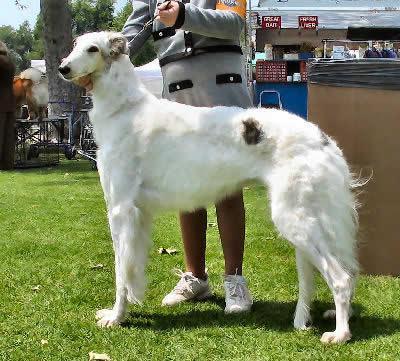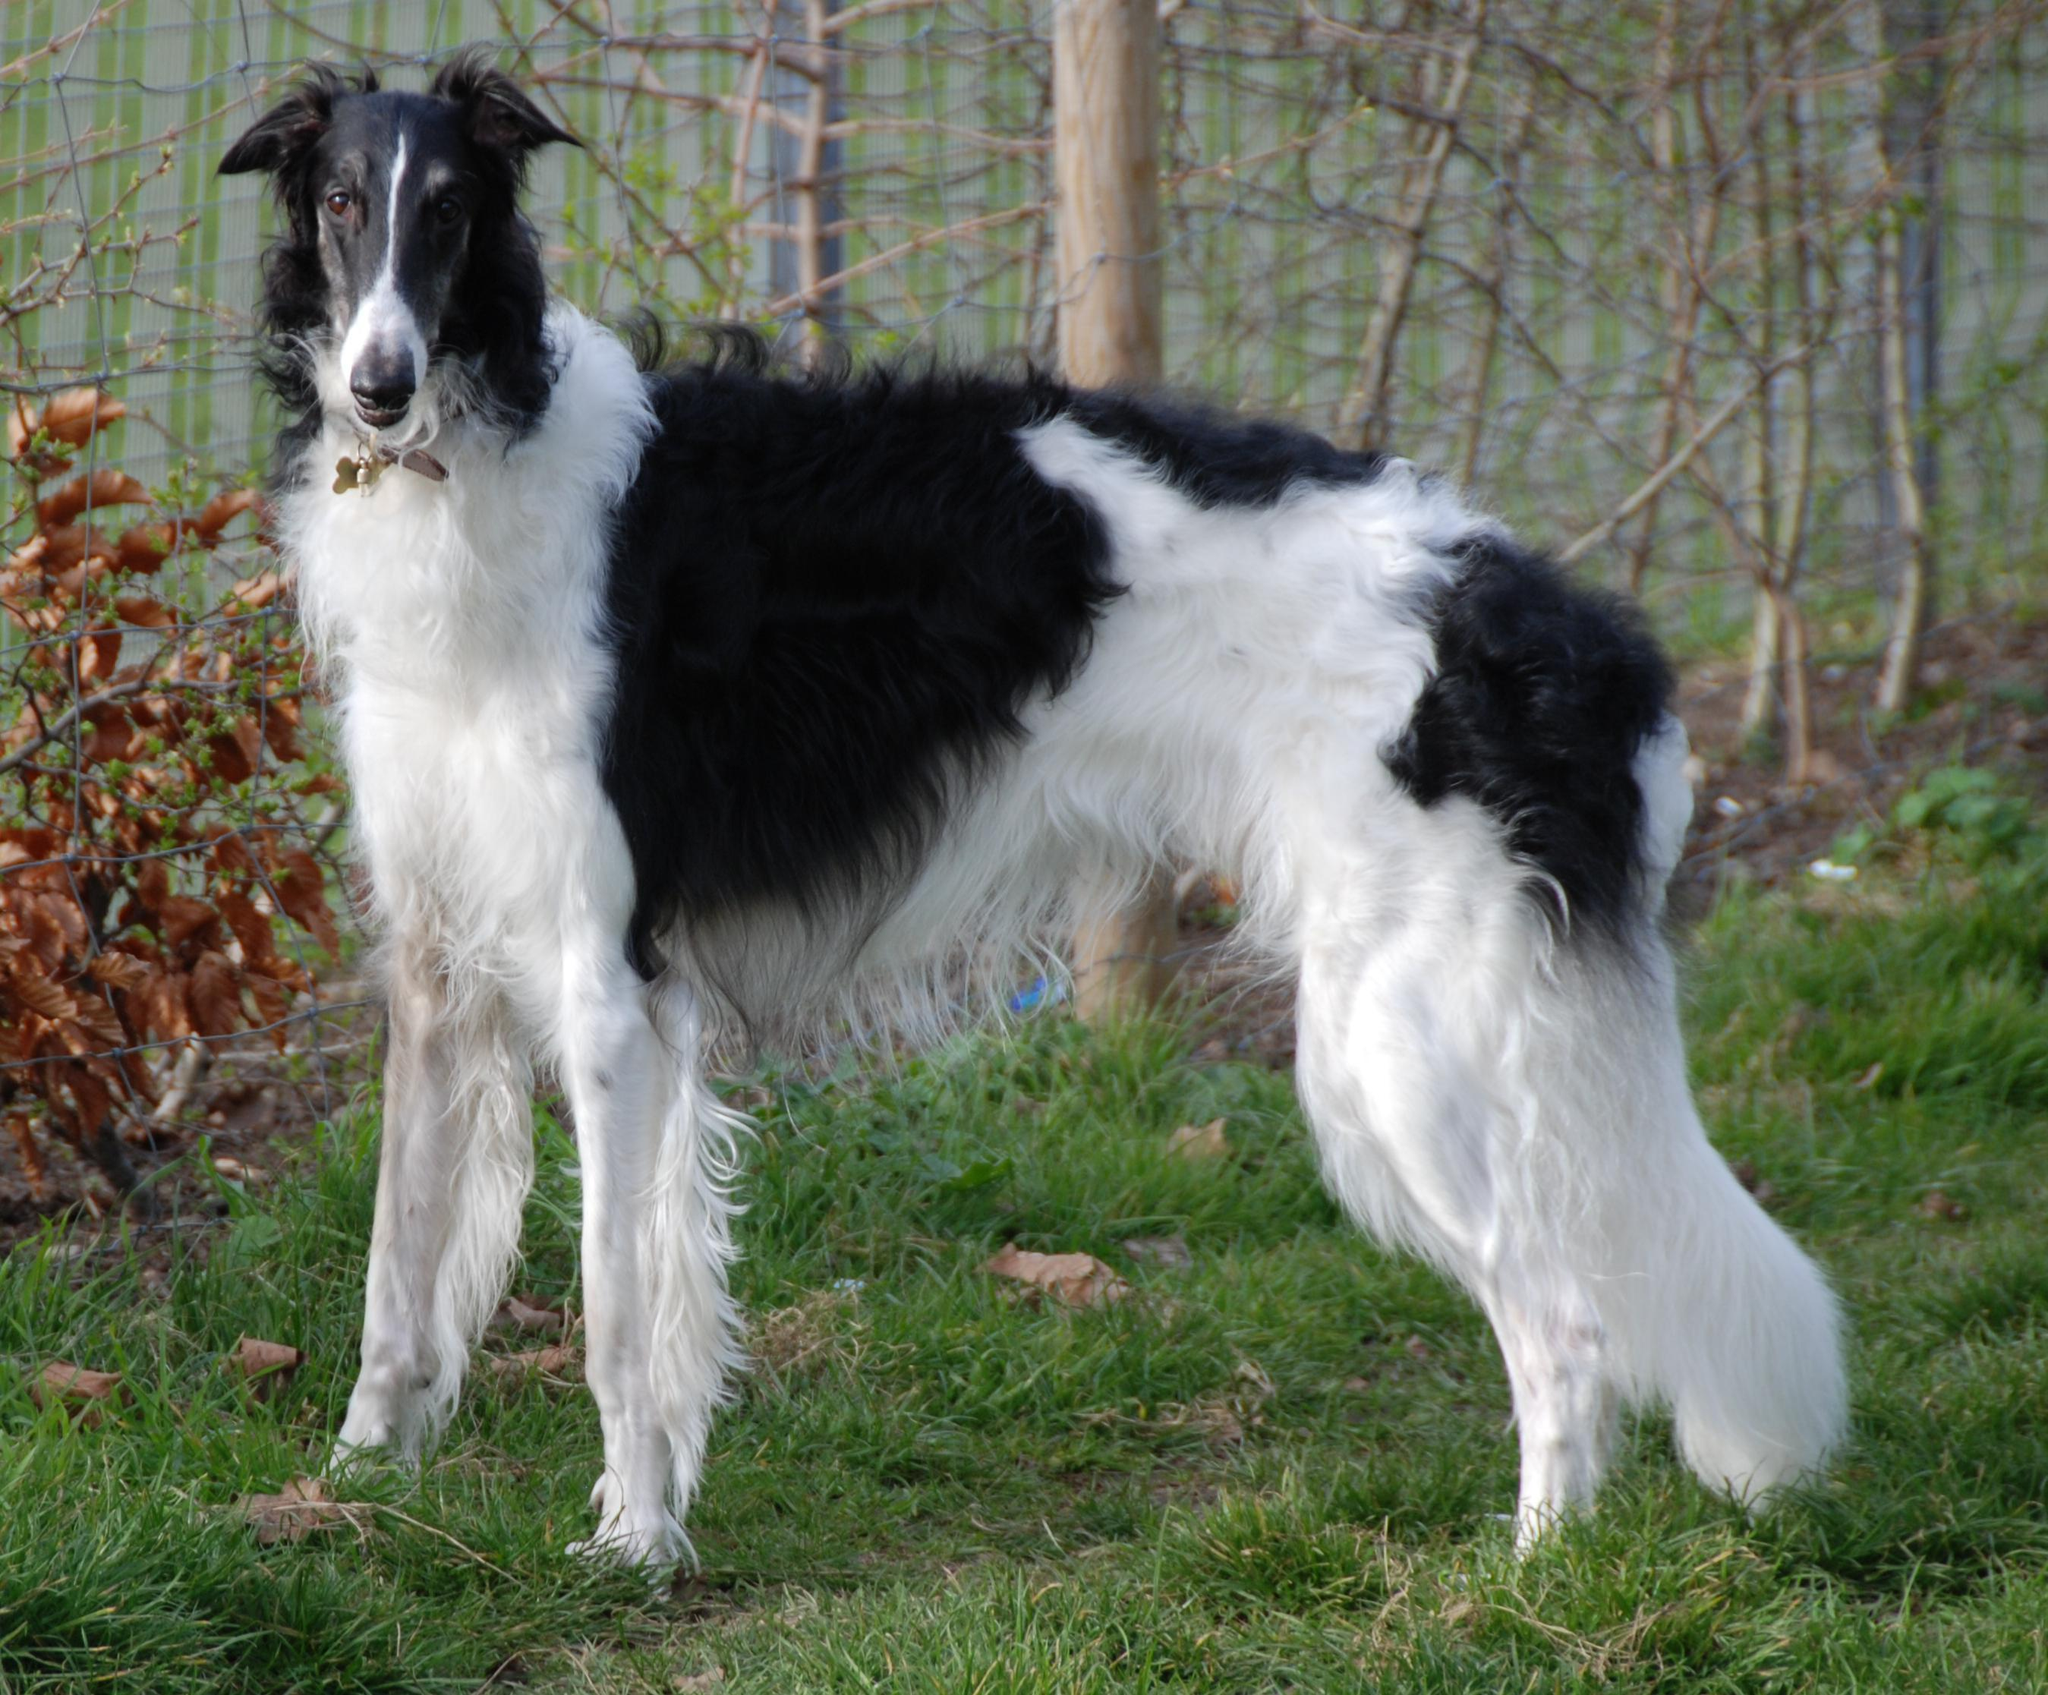The first image is the image on the left, the second image is the image on the right. Assess this claim about the two images: "Each image shows one hound standing instead of walking.". Correct or not? Answer yes or no. Yes. The first image is the image on the left, the second image is the image on the right. Analyze the images presented: Is the assertion "One dog is with a handler and one is not." valid? Answer yes or no. Yes. 